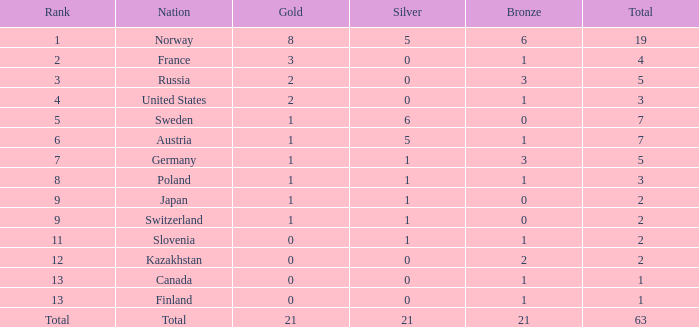What Rank has a gold smaller than 1, and a silver larger than 0? 11.0. 